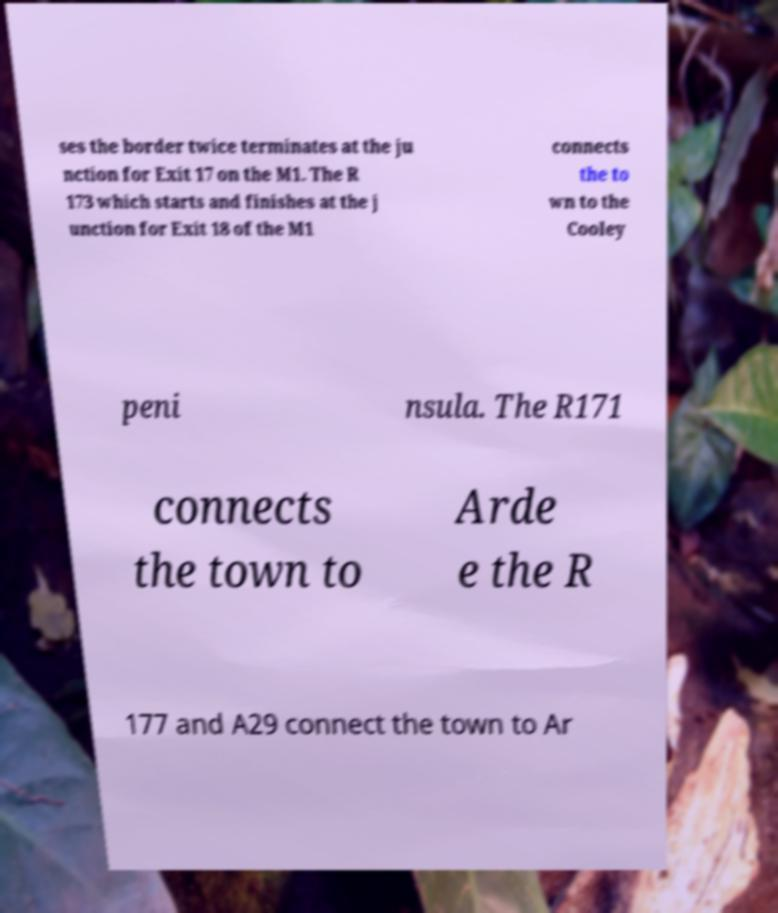Please identify and transcribe the text found in this image. ses the border twice terminates at the ju nction for Exit 17 on the M1. The R 173 which starts and finishes at the j unction for Exit 18 of the M1 connects the to wn to the Cooley peni nsula. The R171 connects the town to Arde e the R 177 and A29 connect the town to Ar 